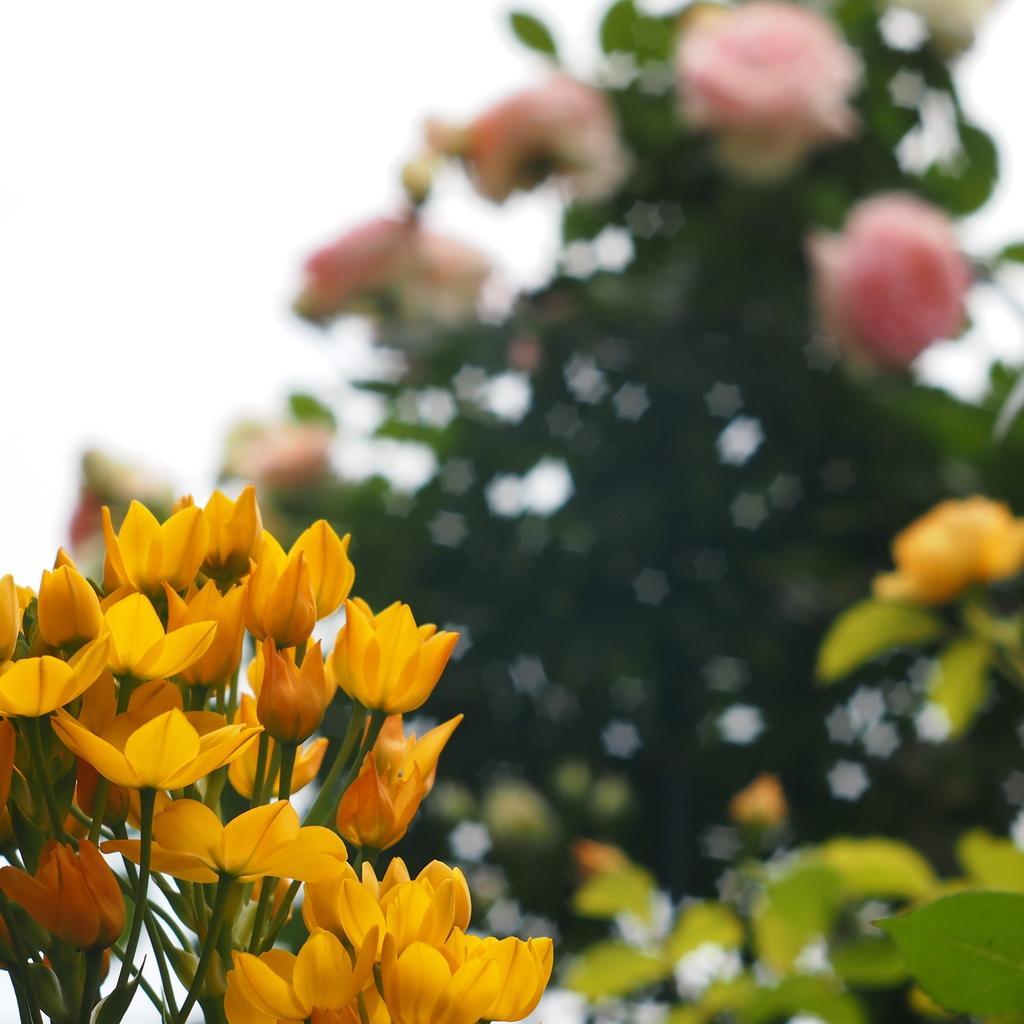Can you describe this image briefly? In the front of the image there is a flower plant. In the background of the image it is blurry.  